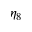Convert formula to latex. <formula><loc_0><loc_0><loc_500><loc_500>\eta _ { 8 }</formula> 